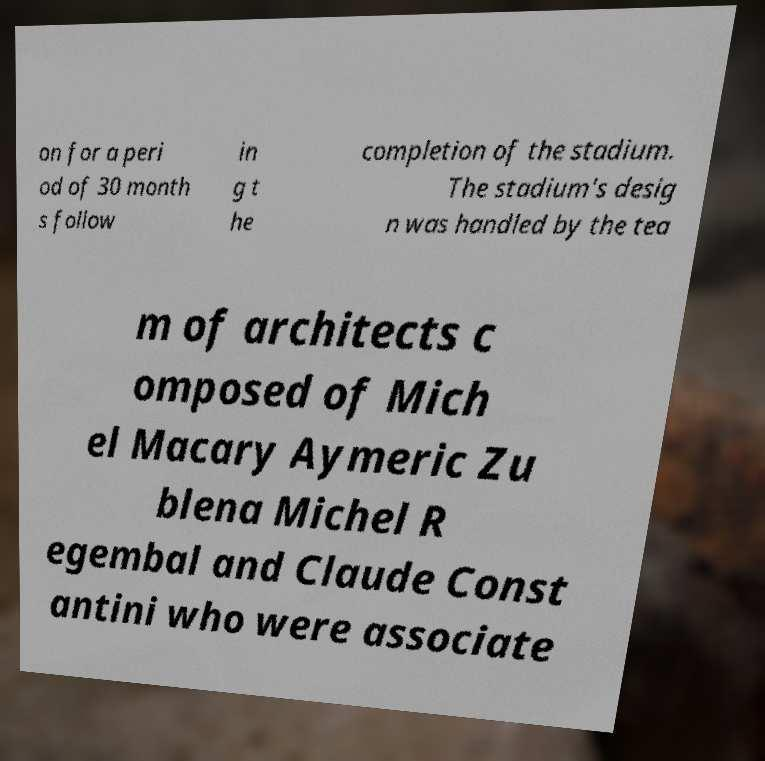Could you extract and type out the text from this image? on for a peri od of 30 month s follow in g t he completion of the stadium. The stadium's desig n was handled by the tea m of architects c omposed of Mich el Macary Aymeric Zu blena Michel R egembal and Claude Const antini who were associate 